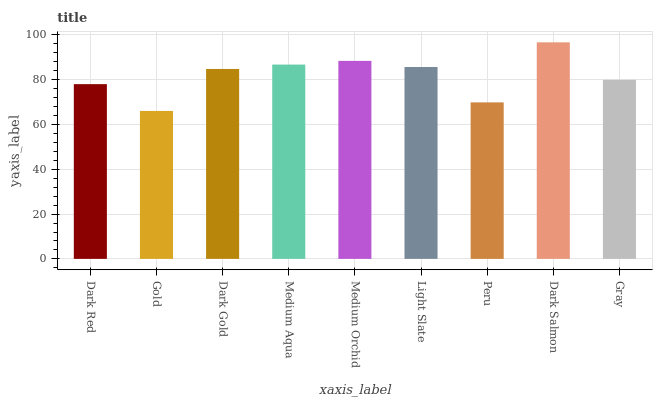Is Gold the minimum?
Answer yes or no. Yes. Is Dark Salmon the maximum?
Answer yes or no. Yes. Is Dark Gold the minimum?
Answer yes or no. No. Is Dark Gold the maximum?
Answer yes or no. No. Is Dark Gold greater than Gold?
Answer yes or no. Yes. Is Gold less than Dark Gold?
Answer yes or no. Yes. Is Gold greater than Dark Gold?
Answer yes or no. No. Is Dark Gold less than Gold?
Answer yes or no. No. Is Dark Gold the high median?
Answer yes or no. Yes. Is Dark Gold the low median?
Answer yes or no. Yes. Is Dark Salmon the high median?
Answer yes or no. No. Is Dark Red the low median?
Answer yes or no. No. 